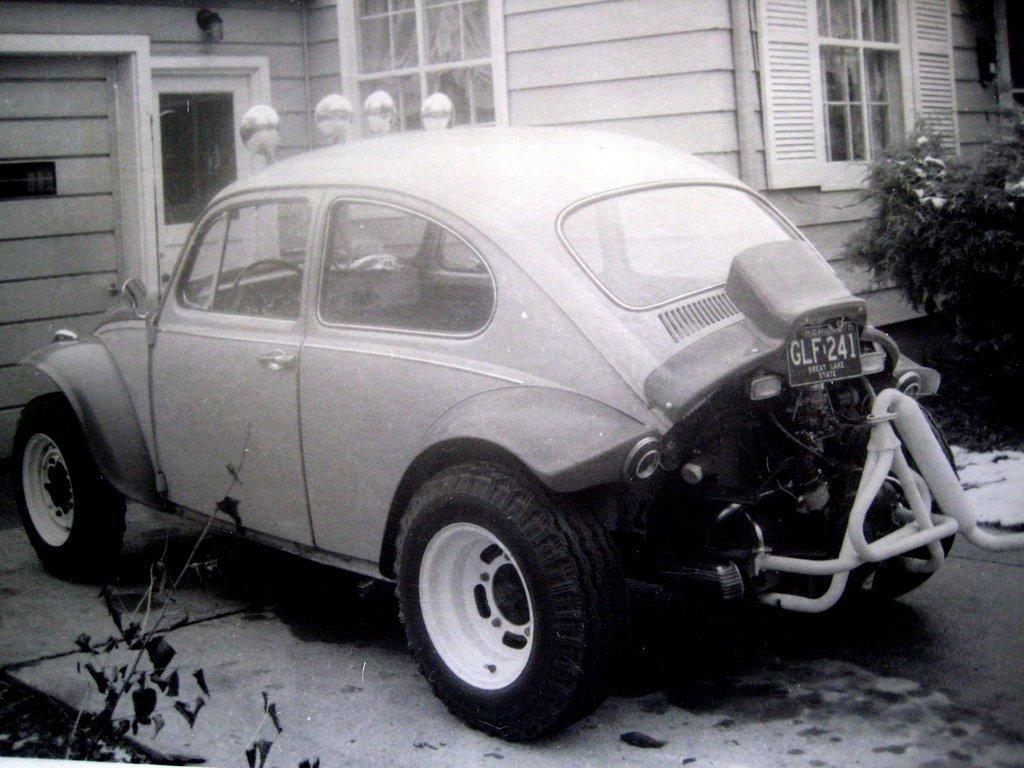Describe this image in one or two sentences. It looks like an old black and white picture. We can see a car parked and behind the car there is a house with windows and a door. On the left and right side of the car there are plants. 